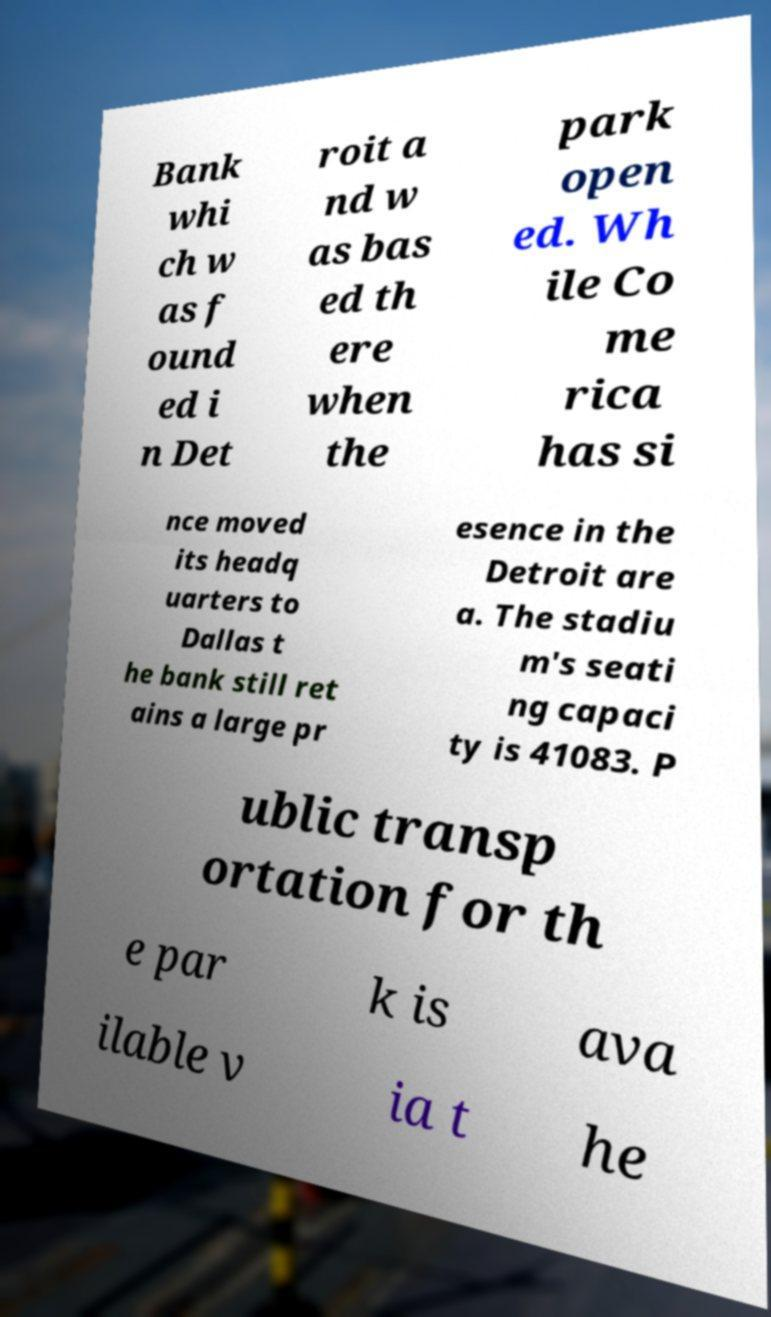Can you accurately transcribe the text from the provided image for me? Bank whi ch w as f ound ed i n Det roit a nd w as bas ed th ere when the park open ed. Wh ile Co me rica has si nce moved its headq uarters to Dallas t he bank still ret ains a large pr esence in the Detroit are a. The stadiu m's seati ng capaci ty is 41083. P ublic transp ortation for th e par k is ava ilable v ia t he 